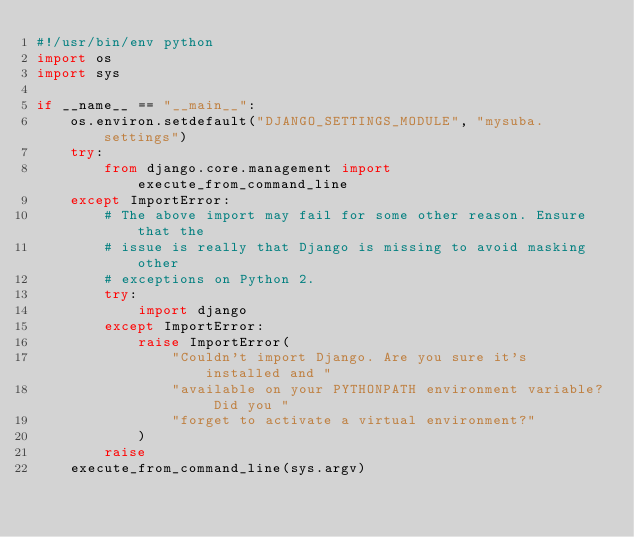Convert code to text. <code><loc_0><loc_0><loc_500><loc_500><_Python_>#!/usr/bin/env python
import os
import sys

if __name__ == "__main__":
    os.environ.setdefault("DJANGO_SETTINGS_MODULE", "mysuba.settings")
    try:
        from django.core.management import execute_from_command_line
    except ImportError:
        # The above import may fail for some other reason. Ensure that the
        # issue is really that Django is missing to avoid masking other
        # exceptions on Python 2.
        try:
            import django
        except ImportError:
            raise ImportError(
                "Couldn't import Django. Are you sure it's installed and "
                "available on your PYTHONPATH environment variable? Did you "
                "forget to activate a virtual environment?"
            )
        raise
    execute_from_command_line(sys.argv)
</code> 